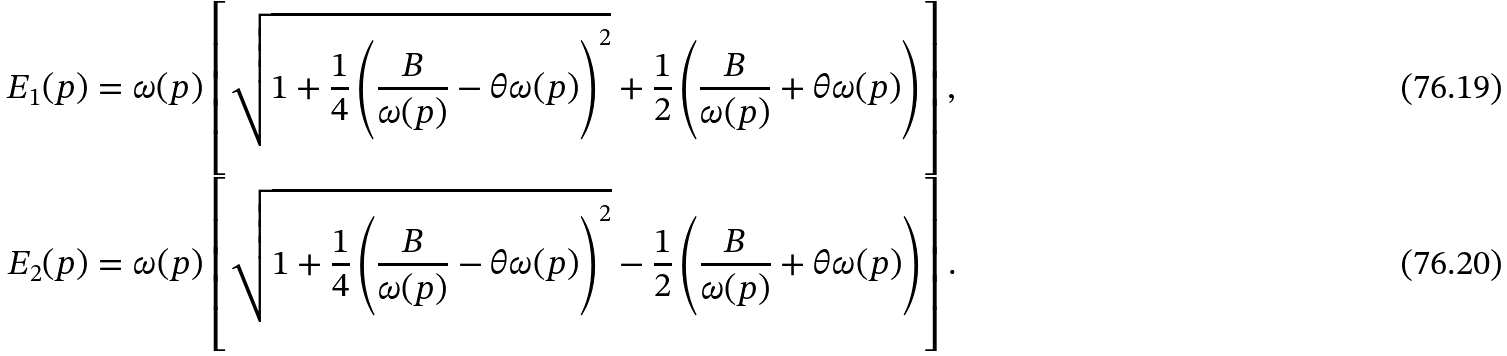Convert formula to latex. <formula><loc_0><loc_0><loc_500><loc_500>E _ { 1 } ( p ) = \omega ( p ) \left [ \sqrt { 1 + \frac { 1 } { 4 } \left ( \frac { B } { \omega ( p ) } - \theta \omega ( p ) \right ) ^ { 2 } } + \frac { 1 } { 2 } \left ( \frac { B } { \omega ( p ) } + \theta \omega ( p ) \right ) \right ] , \\ E _ { 2 } ( p ) = \omega ( p ) \left [ \sqrt { 1 + \frac { 1 } { 4 } \left ( \frac { B } { \omega ( p ) } - \theta \omega ( p ) \right ) ^ { 2 } } - \frac { 1 } { 2 } \left ( \frac { B } { \omega ( p ) } + \theta \omega ( p ) \right ) \right ] .</formula> 